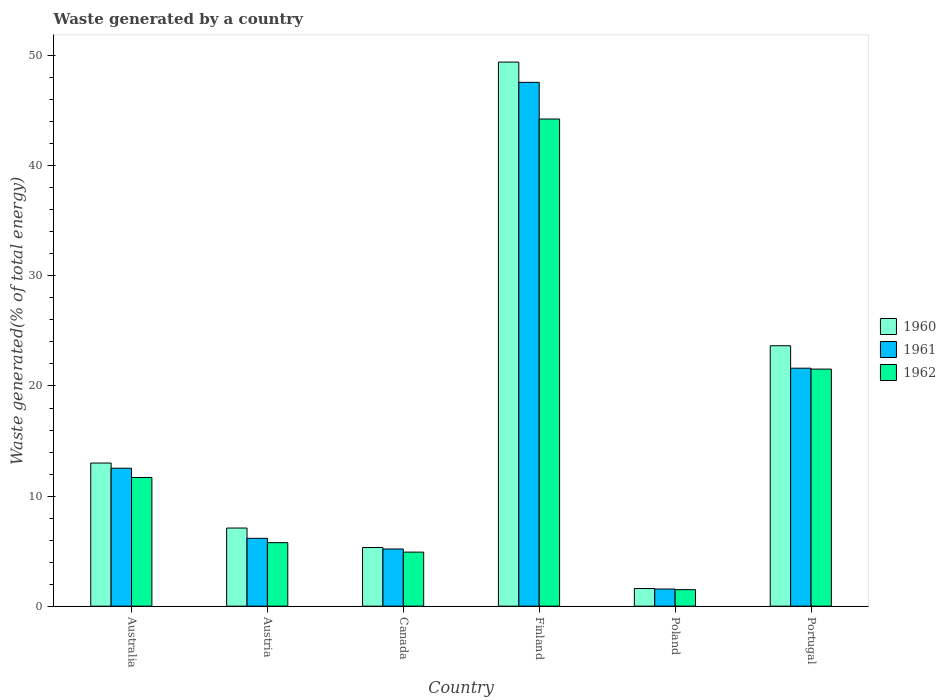How many different coloured bars are there?
Keep it short and to the point. 3. How many groups of bars are there?
Offer a very short reply. 6. Are the number of bars per tick equal to the number of legend labels?
Offer a very short reply. Yes. What is the label of the 5th group of bars from the left?
Offer a terse response. Poland. What is the total waste generated in 1962 in Austria?
Give a very brief answer. 5.77. Across all countries, what is the maximum total waste generated in 1962?
Provide a succinct answer. 44.25. Across all countries, what is the minimum total waste generated in 1962?
Give a very brief answer. 1.5. In which country was the total waste generated in 1960 maximum?
Offer a very short reply. Finland. What is the total total waste generated in 1962 in the graph?
Ensure brevity in your answer.  89.65. What is the difference between the total waste generated in 1961 in Austria and that in Portugal?
Ensure brevity in your answer.  -15.45. What is the difference between the total waste generated in 1962 in Poland and the total waste generated in 1960 in Finland?
Provide a short and direct response. -47.92. What is the average total waste generated in 1962 per country?
Your answer should be very brief. 14.94. What is the difference between the total waste generated of/in 1962 and total waste generated of/in 1961 in Poland?
Your answer should be very brief. -0.06. In how many countries, is the total waste generated in 1961 greater than 4 %?
Offer a terse response. 5. What is the ratio of the total waste generated in 1960 in Austria to that in Finland?
Offer a very short reply. 0.14. Is the difference between the total waste generated in 1962 in Austria and Canada greater than the difference between the total waste generated in 1961 in Austria and Canada?
Your answer should be compact. No. What is the difference between the highest and the second highest total waste generated in 1962?
Make the answer very short. -32.56. What is the difference between the highest and the lowest total waste generated in 1961?
Provide a short and direct response. 46.02. What does the 2nd bar from the left in Poland represents?
Ensure brevity in your answer.  1961. Is it the case that in every country, the sum of the total waste generated in 1961 and total waste generated in 1962 is greater than the total waste generated in 1960?
Provide a succinct answer. Yes. How many bars are there?
Your answer should be compact. 18. Are all the bars in the graph horizontal?
Your answer should be compact. No. How many countries are there in the graph?
Provide a succinct answer. 6. Does the graph contain grids?
Offer a terse response. No. Where does the legend appear in the graph?
Provide a succinct answer. Center right. How many legend labels are there?
Give a very brief answer. 3. What is the title of the graph?
Your answer should be compact. Waste generated by a country. What is the label or title of the Y-axis?
Offer a terse response. Waste generated(% of total energy). What is the Waste generated(% of total energy) of 1960 in Australia?
Provide a short and direct response. 13. What is the Waste generated(% of total energy) of 1961 in Australia?
Offer a terse response. 12.53. What is the Waste generated(% of total energy) of 1962 in Australia?
Your answer should be very brief. 11.69. What is the Waste generated(% of total energy) of 1960 in Austria?
Offer a terse response. 7.1. What is the Waste generated(% of total energy) in 1961 in Austria?
Provide a succinct answer. 6.16. What is the Waste generated(% of total energy) of 1962 in Austria?
Ensure brevity in your answer.  5.77. What is the Waste generated(% of total energy) in 1960 in Canada?
Your answer should be compact. 5.33. What is the Waste generated(% of total energy) of 1961 in Canada?
Give a very brief answer. 5.19. What is the Waste generated(% of total energy) in 1962 in Canada?
Keep it short and to the point. 4.91. What is the Waste generated(% of total energy) in 1960 in Finland?
Give a very brief answer. 49.42. What is the Waste generated(% of total energy) in 1961 in Finland?
Your answer should be very brief. 47.58. What is the Waste generated(% of total energy) of 1962 in Finland?
Provide a short and direct response. 44.25. What is the Waste generated(% of total energy) in 1960 in Poland?
Provide a succinct answer. 1.6. What is the Waste generated(% of total energy) in 1961 in Poland?
Ensure brevity in your answer.  1.56. What is the Waste generated(% of total energy) in 1962 in Poland?
Offer a terse response. 1.5. What is the Waste generated(% of total energy) in 1960 in Portugal?
Your answer should be very brief. 23.66. What is the Waste generated(% of total energy) of 1961 in Portugal?
Your answer should be compact. 21.62. What is the Waste generated(% of total energy) in 1962 in Portugal?
Your answer should be compact. 21.53. Across all countries, what is the maximum Waste generated(% of total energy) of 1960?
Keep it short and to the point. 49.42. Across all countries, what is the maximum Waste generated(% of total energy) in 1961?
Your answer should be compact. 47.58. Across all countries, what is the maximum Waste generated(% of total energy) of 1962?
Provide a succinct answer. 44.25. Across all countries, what is the minimum Waste generated(% of total energy) of 1960?
Offer a very short reply. 1.6. Across all countries, what is the minimum Waste generated(% of total energy) of 1961?
Keep it short and to the point. 1.56. Across all countries, what is the minimum Waste generated(% of total energy) in 1962?
Ensure brevity in your answer.  1.5. What is the total Waste generated(% of total energy) in 1960 in the graph?
Give a very brief answer. 100.11. What is the total Waste generated(% of total energy) of 1961 in the graph?
Provide a short and direct response. 94.65. What is the total Waste generated(% of total energy) of 1962 in the graph?
Your answer should be compact. 89.65. What is the difference between the Waste generated(% of total energy) of 1960 in Australia and that in Austria?
Make the answer very short. 5.9. What is the difference between the Waste generated(% of total energy) in 1961 in Australia and that in Austria?
Make the answer very short. 6.37. What is the difference between the Waste generated(% of total energy) of 1962 in Australia and that in Austria?
Offer a terse response. 5.92. What is the difference between the Waste generated(% of total energy) in 1960 in Australia and that in Canada?
Your answer should be compact. 7.67. What is the difference between the Waste generated(% of total energy) of 1961 in Australia and that in Canada?
Give a very brief answer. 7.34. What is the difference between the Waste generated(% of total energy) of 1962 in Australia and that in Canada?
Ensure brevity in your answer.  6.78. What is the difference between the Waste generated(% of total energy) of 1960 in Australia and that in Finland?
Provide a short and direct response. -36.42. What is the difference between the Waste generated(% of total energy) of 1961 in Australia and that in Finland?
Your answer should be compact. -35.05. What is the difference between the Waste generated(% of total energy) of 1962 in Australia and that in Finland?
Offer a very short reply. -32.56. What is the difference between the Waste generated(% of total energy) of 1960 in Australia and that in Poland?
Keep it short and to the point. 11.4. What is the difference between the Waste generated(% of total energy) of 1961 in Australia and that in Poland?
Keep it short and to the point. 10.97. What is the difference between the Waste generated(% of total energy) of 1962 in Australia and that in Poland?
Your response must be concise. 10.19. What is the difference between the Waste generated(% of total energy) in 1960 in Australia and that in Portugal?
Provide a succinct answer. -10.65. What is the difference between the Waste generated(% of total energy) in 1961 in Australia and that in Portugal?
Make the answer very short. -9.09. What is the difference between the Waste generated(% of total energy) in 1962 in Australia and that in Portugal?
Make the answer very short. -9.84. What is the difference between the Waste generated(% of total energy) of 1960 in Austria and that in Canada?
Provide a succinct answer. 1.77. What is the difference between the Waste generated(% of total energy) of 1961 in Austria and that in Canada?
Keep it short and to the point. 0.97. What is the difference between the Waste generated(% of total energy) of 1962 in Austria and that in Canada?
Your answer should be very brief. 0.86. What is the difference between the Waste generated(% of total energy) in 1960 in Austria and that in Finland?
Your answer should be compact. -42.33. What is the difference between the Waste generated(% of total energy) of 1961 in Austria and that in Finland?
Keep it short and to the point. -41.42. What is the difference between the Waste generated(% of total energy) of 1962 in Austria and that in Finland?
Give a very brief answer. -38.48. What is the difference between the Waste generated(% of total energy) in 1960 in Austria and that in Poland?
Give a very brief answer. 5.49. What is the difference between the Waste generated(% of total energy) in 1961 in Austria and that in Poland?
Provide a short and direct response. 4.61. What is the difference between the Waste generated(% of total energy) in 1962 in Austria and that in Poland?
Make the answer very short. 4.27. What is the difference between the Waste generated(% of total energy) of 1960 in Austria and that in Portugal?
Your response must be concise. -16.56. What is the difference between the Waste generated(% of total energy) of 1961 in Austria and that in Portugal?
Provide a succinct answer. -15.45. What is the difference between the Waste generated(% of total energy) of 1962 in Austria and that in Portugal?
Provide a succinct answer. -15.76. What is the difference between the Waste generated(% of total energy) in 1960 in Canada and that in Finland?
Make the answer very short. -44.1. What is the difference between the Waste generated(% of total energy) of 1961 in Canada and that in Finland?
Provide a short and direct response. -42.39. What is the difference between the Waste generated(% of total energy) of 1962 in Canada and that in Finland?
Offer a very short reply. -39.34. What is the difference between the Waste generated(% of total energy) in 1960 in Canada and that in Poland?
Your answer should be compact. 3.72. What is the difference between the Waste generated(% of total energy) of 1961 in Canada and that in Poland?
Ensure brevity in your answer.  3.64. What is the difference between the Waste generated(% of total energy) of 1962 in Canada and that in Poland?
Your answer should be very brief. 3.41. What is the difference between the Waste generated(% of total energy) of 1960 in Canada and that in Portugal?
Offer a very short reply. -18.33. What is the difference between the Waste generated(% of total energy) in 1961 in Canada and that in Portugal?
Your answer should be very brief. -16.42. What is the difference between the Waste generated(% of total energy) of 1962 in Canada and that in Portugal?
Make the answer very short. -16.62. What is the difference between the Waste generated(% of total energy) in 1960 in Finland and that in Poland?
Provide a succinct answer. 47.82. What is the difference between the Waste generated(% of total energy) of 1961 in Finland and that in Poland?
Your answer should be very brief. 46.02. What is the difference between the Waste generated(% of total energy) of 1962 in Finland and that in Poland?
Ensure brevity in your answer.  42.75. What is the difference between the Waste generated(% of total energy) of 1960 in Finland and that in Portugal?
Offer a terse response. 25.77. What is the difference between the Waste generated(% of total energy) of 1961 in Finland and that in Portugal?
Make the answer very short. 25.96. What is the difference between the Waste generated(% of total energy) of 1962 in Finland and that in Portugal?
Make the answer very short. 22.72. What is the difference between the Waste generated(% of total energy) in 1960 in Poland and that in Portugal?
Make the answer very short. -22.05. What is the difference between the Waste generated(% of total energy) of 1961 in Poland and that in Portugal?
Ensure brevity in your answer.  -20.06. What is the difference between the Waste generated(% of total energy) of 1962 in Poland and that in Portugal?
Offer a terse response. -20.03. What is the difference between the Waste generated(% of total energy) in 1960 in Australia and the Waste generated(% of total energy) in 1961 in Austria?
Give a very brief answer. 6.84. What is the difference between the Waste generated(% of total energy) in 1960 in Australia and the Waste generated(% of total energy) in 1962 in Austria?
Ensure brevity in your answer.  7.23. What is the difference between the Waste generated(% of total energy) of 1961 in Australia and the Waste generated(% of total energy) of 1962 in Austria?
Your answer should be very brief. 6.76. What is the difference between the Waste generated(% of total energy) of 1960 in Australia and the Waste generated(% of total energy) of 1961 in Canada?
Offer a very short reply. 7.81. What is the difference between the Waste generated(% of total energy) in 1960 in Australia and the Waste generated(% of total energy) in 1962 in Canada?
Ensure brevity in your answer.  8.09. What is the difference between the Waste generated(% of total energy) of 1961 in Australia and the Waste generated(% of total energy) of 1962 in Canada?
Provide a short and direct response. 7.62. What is the difference between the Waste generated(% of total energy) of 1960 in Australia and the Waste generated(% of total energy) of 1961 in Finland?
Provide a short and direct response. -34.58. What is the difference between the Waste generated(% of total energy) in 1960 in Australia and the Waste generated(% of total energy) in 1962 in Finland?
Ensure brevity in your answer.  -31.25. What is the difference between the Waste generated(% of total energy) of 1961 in Australia and the Waste generated(% of total energy) of 1962 in Finland?
Keep it short and to the point. -31.72. What is the difference between the Waste generated(% of total energy) of 1960 in Australia and the Waste generated(% of total energy) of 1961 in Poland?
Offer a terse response. 11.44. What is the difference between the Waste generated(% of total energy) in 1960 in Australia and the Waste generated(% of total energy) in 1962 in Poland?
Your answer should be very brief. 11.5. What is the difference between the Waste generated(% of total energy) of 1961 in Australia and the Waste generated(% of total energy) of 1962 in Poland?
Keep it short and to the point. 11.03. What is the difference between the Waste generated(% of total energy) of 1960 in Australia and the Waste generated(% of total energy) of 1961 in Portugal?
Your answer should be compact. -8.62. What is the difference between the Waste generated(% of total energy) in 1960 in Australia and the Waste generated(% of total energy) in 1962 in Portugal?
Provide a short and direct response. -8.53. What is the difference between the Waste generated(% of total energy) in 1961 in Australia and the Waste generated(% of total energy) in 1962 in Portugal?
Offer a terse response. -9. What is the difference between the Waste generated(% of total energy) of 1960 in Austria and the Waste generated(% of total energy) of 1961 in Canada?
Make the answer very short. 1.9. What is the difference between the Waste generated(% of total energy) in 1960 in Austria and the Waste generated(% of total energy) in 1962 in Canada?
Offer a very short reply. 2.19. What is the difference between the Waste generated(% of total energy) of 1961 in Austria and the Waste generated(% of total energy) of 1962 in Canada?
Offer a very short reply. 1.25. What is the difference between the Waste generated(% of total energy) of 1960 in Austria and the Waste generated(% of total energy) of 1961 in Finland?
Provide a succinct answer. -40.48. What is the difference between the Waste generated(% of total energy) in 1960 in Austria and the Waste generated(% of total energy) in 1962 in Finland?
Your answer should be compact. -37.15. What is the difference between the Waste generated(% of total energy) in 1961 in Austria and the Waste generated(% of total energy) in 1962 in Finland?
Your response must be concise. -38.09. What is the difference between the Waste generated(% of total energy) in 1960 in Austria and the Waste generated(% of total energy) in 1961 in Poland?
Offer a very short reply. 5.54. What is the difference between the Waste generated(% of total energy) of 1960 in Austria and the Waste generated(% of total energy) of 1962 in Poland?
Ensure brevity in your answer.  5.6. What is the difference between the Waste generated(% of total energy) of 1961 in Austria and the Waste generated(% of total energy) of 1962 in Poland?
Provide a short and direct response. 4.67. What is the difference between the Waste generated(% of total energy) of 1960 in Austria and the Waste generated(% of total energy) of 1961 in Portugal?
Your answer should be compact. -14.52. What is the difference between the Waste generated(% of total energy) of 1960 in Austria and the Waste generated(% of total energy) of 1962 in Portugal?
Your answer should be very brief. -14.44. What is the difference between the Waste generated(% of total energy) of 1961 in Austria and the Waste generated(% of total energy) of 1962 in Portugal?
Your answer should be compact. -15.37. What is the difference between the Waste generated(% of total energy) in 1960 in Canada and the Waste generated(% of total energy) in 1961 in Finland?
Offer a very short reply. -42.25. What is the difference between the Waste generated(% of total energy) in 1960 in Canada and the Waste generated(% of total energy) in 1962 in Finland?
Keep it short and to the point. -38.92. What is the difference between the Waste generated(% of total energy) of 1961 in Canada and the Waste generated(% of total energy) of 1962 in Finland?
Provide a short and direct response. -39.06. What is the difference between the Waste generated(% of total energy) in 1960 in Canada and the Waste generated(% of total energy) in 1961 in Poland?
Offer a terse response. 3.77. What is the difference between the Waste generated(% of total energy) in 1960 in Canada and the Waste generated(% of total energy) in 1962 in Poland?
Your answer should be very brief. 3.83. What is the difference between the Waste generated(% of total energy) of 1961 in Canada and the Waste generated(% of total energy) of 1962 in Poland?
Provide a succinct answer. 3.7. What is the difference between the Waste generated(% of total energy) in 1960 in Canada and the Waste generated(% of total energy) in 1961 in Portugal?
Your answer should be very brief. -16.29. What is the difference between the Waste generated(% of total energy) of 1960 in Canada and the Waste generated(% of total energy) of 1962 in Portugal?
Make the answer very short. -16.21. What is the difference between the Waste generated(% of total energy) of 1961 in Canada and the Waste generated(% of total energy) of 1962 in Portugal?
Offer a terse response. -16.34. What is the difference between the Waste generated(% of total energy) in 1960 in Finland and the Waste generated(% of total energy) in 1961 in Poland?
Your response must be concise. 47.86. What is the difference between the Waste generated(% of total energy) in 1960 in Finland and the Waste generated(% of total energy) in 1962 in Poland?
Your answer should be very brief. 47.92. What is the difference between the Waste generated(% of total energy) in 1961 in Finland and the Waste generated(% of total energy) in 1962 in Poland?
Provide a short and direct response. 46.08. What is the difference between the Waste generated(% of total energy) of 1960 in Finland and the Waste generated(% of total energy) of 1961 in Portugal?
Keep it short and to the point. 27.81. What is the difference between the Waste generated(% of total energy) of 1960 in Finland and the Waste generated(% of total energy) of 1962 in Portugal?
Ensure brevity in your answer.  27.89. What is the difference between the Waste generated(% of total energy) in 1961 in Finland and the Waste generated(% of total energy) in 1962 in Portugal?
Your answer should be very brief. 26.05. What is the difference between the Waste generated(% of total energy) in 1960 in Poland and the Waste generated(% of total energy) in 1961 in Portugal?
Offer a terse response. -20.01. What is the difference between the Waste generated(% of total energy) in 1960 in Poland and the Waste generated(% of total energy) in 1962 in Portugal?
Provide a short and direct response. -19.93. What is the difference between the Waste generated(% of total energy) in 1961 in Poland and the Waste generated(% of total energy) in 1962 in Portugal?
Your response must be concise. -19.98. What is the average Waste generated(% of total energy) in 1960 per country?
Your answer should be very brief. 16.68. What is the average Waste generated(% of total energy) in 1961 per country?
Give a very brief answer. 15.77. What is the average Waste generated(% of total energy) of 1962 per country?
Keep it short and to the point. 14.94. What is the difference between the Waste generated(% of total energy) in 1960 and Waste generated(% of total energy) in 1961 in Australia?
Ensure brevity in your answer.  0.47. What is the difference between the Waste generated(% of total energy) of 1960 and Waste generated(% of total energy) of 1962 in Australia?
Ensure brevity in your answer.  1.31. What is the difference between the Waste generated(% of total energy) in 1961 and Waste generated(% of total energy) in 1962 in Australia?
Make the answer very short. 0.84. What is the difference between the Waste generated(% of total energy) of 1960 and Waste generated(% of total energy) of 1961 in Austria?
Your answer should be very brief. 0.93. What is the difference between the Waste generated(% of total energy) in 1960 and Waste generated(% of total energy) in 1962 in Austria?
Give a very brief answer. 1.33. What is the difference between the Waste generated(% of total energy) in 1961 and Waste generated(% of total energy) in 1962 in Austria?
Keep it short and to the point. 0.4. What is the difference between the Waste generated(% of total energy) of 1960 and Waste generated(% of total energy) of 1961 in Canada?
Your response must be concise. 0.13. What is the difference between the Waste generated(% of total energy) of 1960 and Waste generated(% of total energy) of 1962 in Canada?
Provide a short and direct response. 0.42. What is the difference between the Waste generated(% of total energy) of 1961 and Waste generated(% of total energy) of 1962 in Canada?
Provide a succinct answer. 0.28. What is the difference between the Waste generated(% of total energy) of 1960 and Waste generated(% of total energy) of 1961 in Finland?
Provide a succinct answer. 1.84. What is the difference between the Waste generated(% of total energy) in 1960 and Waste generated(% of total energy) in 1962 in Finland?
Your response must be concise. 5.17. What is the difference between the Waste generated(% of total energy) in 1961 and Waste generated(% of total energy) in 1962 in Finland?
Your answer should be compact. 3.33. What is the difference between the Waste generated(% of total energy) in 1960 and Waste generated(% of total energy) in 1961 in Poland?
Ensure brevity in your answer.  0.05. What is the difference between the Waste generated(% of total energy) of 1960 and Waste generated(% of total energy) of 1962 in Poland?
Ensure brevity in your answer.  0.11. What is the difference between the Waste generated(% of total energy) in 1961 and Waste generated(% of total energy) in 1962 in Poland?
Offer a terse response. 0.06. What is the difference between the Waste generated(% of total energy) in 1960 and Waste generated(% of total energy) in 1961 in Portugal?
Your response must be concise. 2.04. What is the difference between the Waste generated(% of total energy) of 1960 and Waste generated(% of total energy) of 1962 in Portugal?
Keep it short and to the point. 2.12. What is the difference between the Waste generated(% of total energy) in 1961 and Waste generated(% of total energy) in 1962 in Portugal?
Your answer should be very brief. 0.08. What is the ratio of the Waste generated(% of total energy) in 1960 in Australia to that in Austria?
Ensure brevity in your answer.  1.83. What is the ratio of the Waste generated(% of total energy) of 1961 in Australia to that in Austria?
Make the answer very short. 2.03. What is the ratio of the Waste generated(% of total energy) in 1962 in Australia to that in Austria?
Your answer should be very brief. 2.03. What is the ratio of the Waste generated(% of total energy) of 1960 in Australia to that in Canada?
Make the answer very short. 2.44. What is the ratio of the Waste generated(% of total energy) of 1961 in Australia to that in Canada?
Offer a terse response. 2.41. What is the ratio of the Waste generated(% of total energy) of 1962 in Australia to that in Canada?
Provide a short and direct response. 2.38. What is the ratio of the Waste generated(% of total energy) in 1960 in Australia to that in Finland?
Your answer should be compact. 0.26. What is the ratio of the Waste generated(% of total energy) in 1961 in Australia to that in Finland?
Your response must be concise. 0.26. What is the ratio of the Waste generated(% of total energy) in 1962 in Australia to that in Finland?
Your answer should be very brief. 0.26. What is the ratio of the Waste generated(% of total energy) in 1960 in Australia to that in Poland?
Offer a terse response. 8.1. What is the ratio of the Waste generated(% of total energy) of 1961 in Australia to that in Poland?
Your answer should be very brief. 8.04. What is the ratio of the Waste generated(% of total energy) of 1962 in Australia to that in Poland?
Your answer should be compact. 7.8. What is the ratio of the Waste generated(% of total energy) of 1960 in Australia to that in Portugal?
Provide a succinct answer. 0.55. What is the ratio of the Waste generated(% of total energy) in 1961 in Australia to that in Portugal?
Provide a succinct answer. 0.58. What is the ratio of the Waste generated(% of total energy) of 1962 in Australia to that in Portugal?
Offer a very short reply. 0.54. What is the ratio of the Waste generated(% of total energy) of 1960 in Austria to that in Canada?
Keep it short and to the point. 1.33. What is the ratio of the Waste generated(% of total energy) in 1961 in Austria to that in Canada?
Your answer should be compact. 1.19. What is the ratio of the Waste generated(% of total energy) of 1962 in Austria to that in Canada?
Your answer should be compact. 1.17. What is the ratio of the Waste generated(% of total energy) of 1960 in Austria to that in Finland?
Keep it short and to the point. 0.14. What is the ratio of the Waste generated(% of total energy) in 1961 in Austria to that in Finland?
Ensure brevity in your answer.  0.13. What is the ratio of the Waste generated(% of total energy) in 1962 in Austria to that in Finland?
Your answer should be compact. 0.13. What is the ratio of the Waste generated(% of total energy) in 1960 in Austria to that in Poland?
Your answer should be very brief. 4.42. What is the ratio of the Waste generated(% of total energy) of 1961 in Austria to that in Poland?
Provide a succinct answer. 3.96. What is the ratio of the Waste generated(% of total energy) of 1962 in Austria to that in Poland?
Keep it short and to the point. 3.85. What is the ratio of the Waste generated(% of total energy) in 1960 in Austria to that in Portugal?
Make the answer very short. 0.3. What is the ratio of the Waste generated(% of total energy) of 1961 in Austria to that in Portugal?
Keep it short and to the point. 0.29. What is the ratio of the Waste generated(% of total energy) of 1962 in Austria to that in Portugal?
Ensure brevity in your answer.  0.27. What is the ratio of the Waste generated(% of total energy) in 1960 in Canada to that in Finland?
Offer a very short reply. 0.11. What is the ratio of the Waste generated(% of total energy) of 1961 in Canada to that in Finland?
Your response must be concise. 0.11. What is the ratio of the Waste generated(% of total energy) of 1962 in Canada to that in Finland?
Give a very brief answer. 0.11. What is the ratio of the Waste generated(% of total energy) in 1960 in Canada to that in Poland?
Give a very brief answer. 3.32. What is the ratio of the Waste generated(% of total energy) in 1961 in Canada to that in Poland?
Ensure brevity in your answer.  3.33. What is the ratio of the Waste generated(% of total energy) in 1962 in Canada to that in Poland?
Offer a very short reply. 3.28. What is the ratio of the Waste generated(% of total energy) of 1960 in Canada to that in Portugal?
Keep it short and to the point. 0.23. What is the ratio of the Waste generated(% of total energy) in 1961 in Canada to that in Portugal?
Keep it short and to the point. 0.24. What is the ratio of the Waste generated(% of total energy) of 1962 in Canada to that in Portugal?
Your answer should be compact. 0.23. What is the ratio of the Waste generated(% of total energy) in 1960 in Finland to that in Poland?
Ensure brevity in your answer.  30.8. What is the ratio of the Waste generated(% of total energy) in 1961 in Finland to that in Poland?
Your answer should be very brief. 30.53. What is the ratio of the Waste generated(% of total energy) of 1962 in Finland to that in Poland?
Your response must be concise. 29.52. What is the ratio of the Waste generated(% of total energy) of 1960 in Finland to that in Portugal?
Provide a short and direct response. 2.09. What is the ratio of the Waste generated(% of total energy) of 1961 in Finland to that in Portugal?
Keep it short and to the point. 2.2. What is the ratio of the Waste generated(% of total energy) of 1962 in Finland to that in Portugal?
Your answer should be very brief. 2.05. What is the ratio of the Waste generated(% of total energy) in 1960 in Poland to that in Portugal?
Your response must be concise. 0.07. What is the ratio of the Waste generated(% of total energy) in 1961 in Poland to that in Portugal?
Provide a short and direct response. 0.07. What is the ratio of the Waste generated(% of total energy) in 1962 in Poland to that in Portugal?
Offer a terse response. 0.07. What is the difference between the highest and the second highest Waste generated(% of total energy) of 1960?
Provide a short and direct response. 25.77. What is the difference between the highest and the second highest Waste generated(% of total energy) of 1961?
Offer a terse response. 25.96. What is the difference between the highest and the second highest Waste generated(% of total energy) of 1962?
Provide a short and direct response. 22.72. What is the difference between the highest and the lowest Waste generated(% of total energy) of 1960?
Offer a terse response. 47.82. What is the difference between the highest and the lowest Waste generated(% of total energy) in 1961?
Your response must be concise. 46.02. What is the difference between the highest and the lowest Waste generated(% of total energy) in 1962?
Keep it short and to the point. 42.75. 